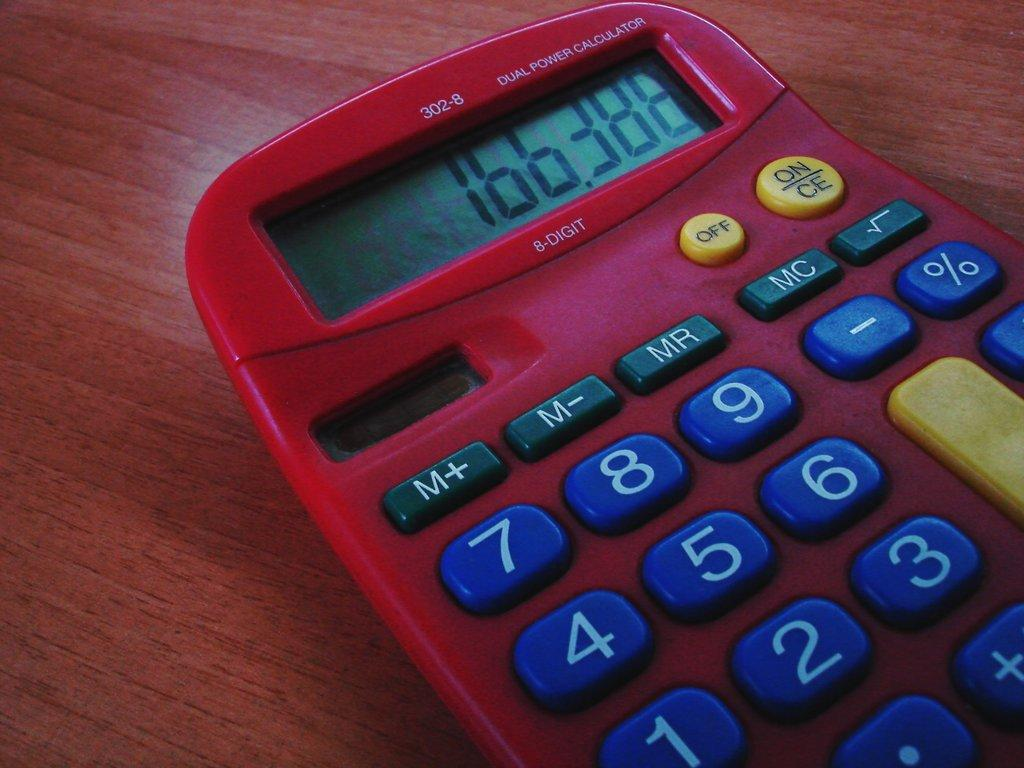What type of device is in the image? There is a red color calculator in the image. What colors are the buttons on the calculator? The calculator has blue, black, and yellow color buttons. What is the color of the table the calculator is placed on? The calculator is on a maroon color table. Where is the toothbrush located in the image? There is no toothbrush present in the image. 